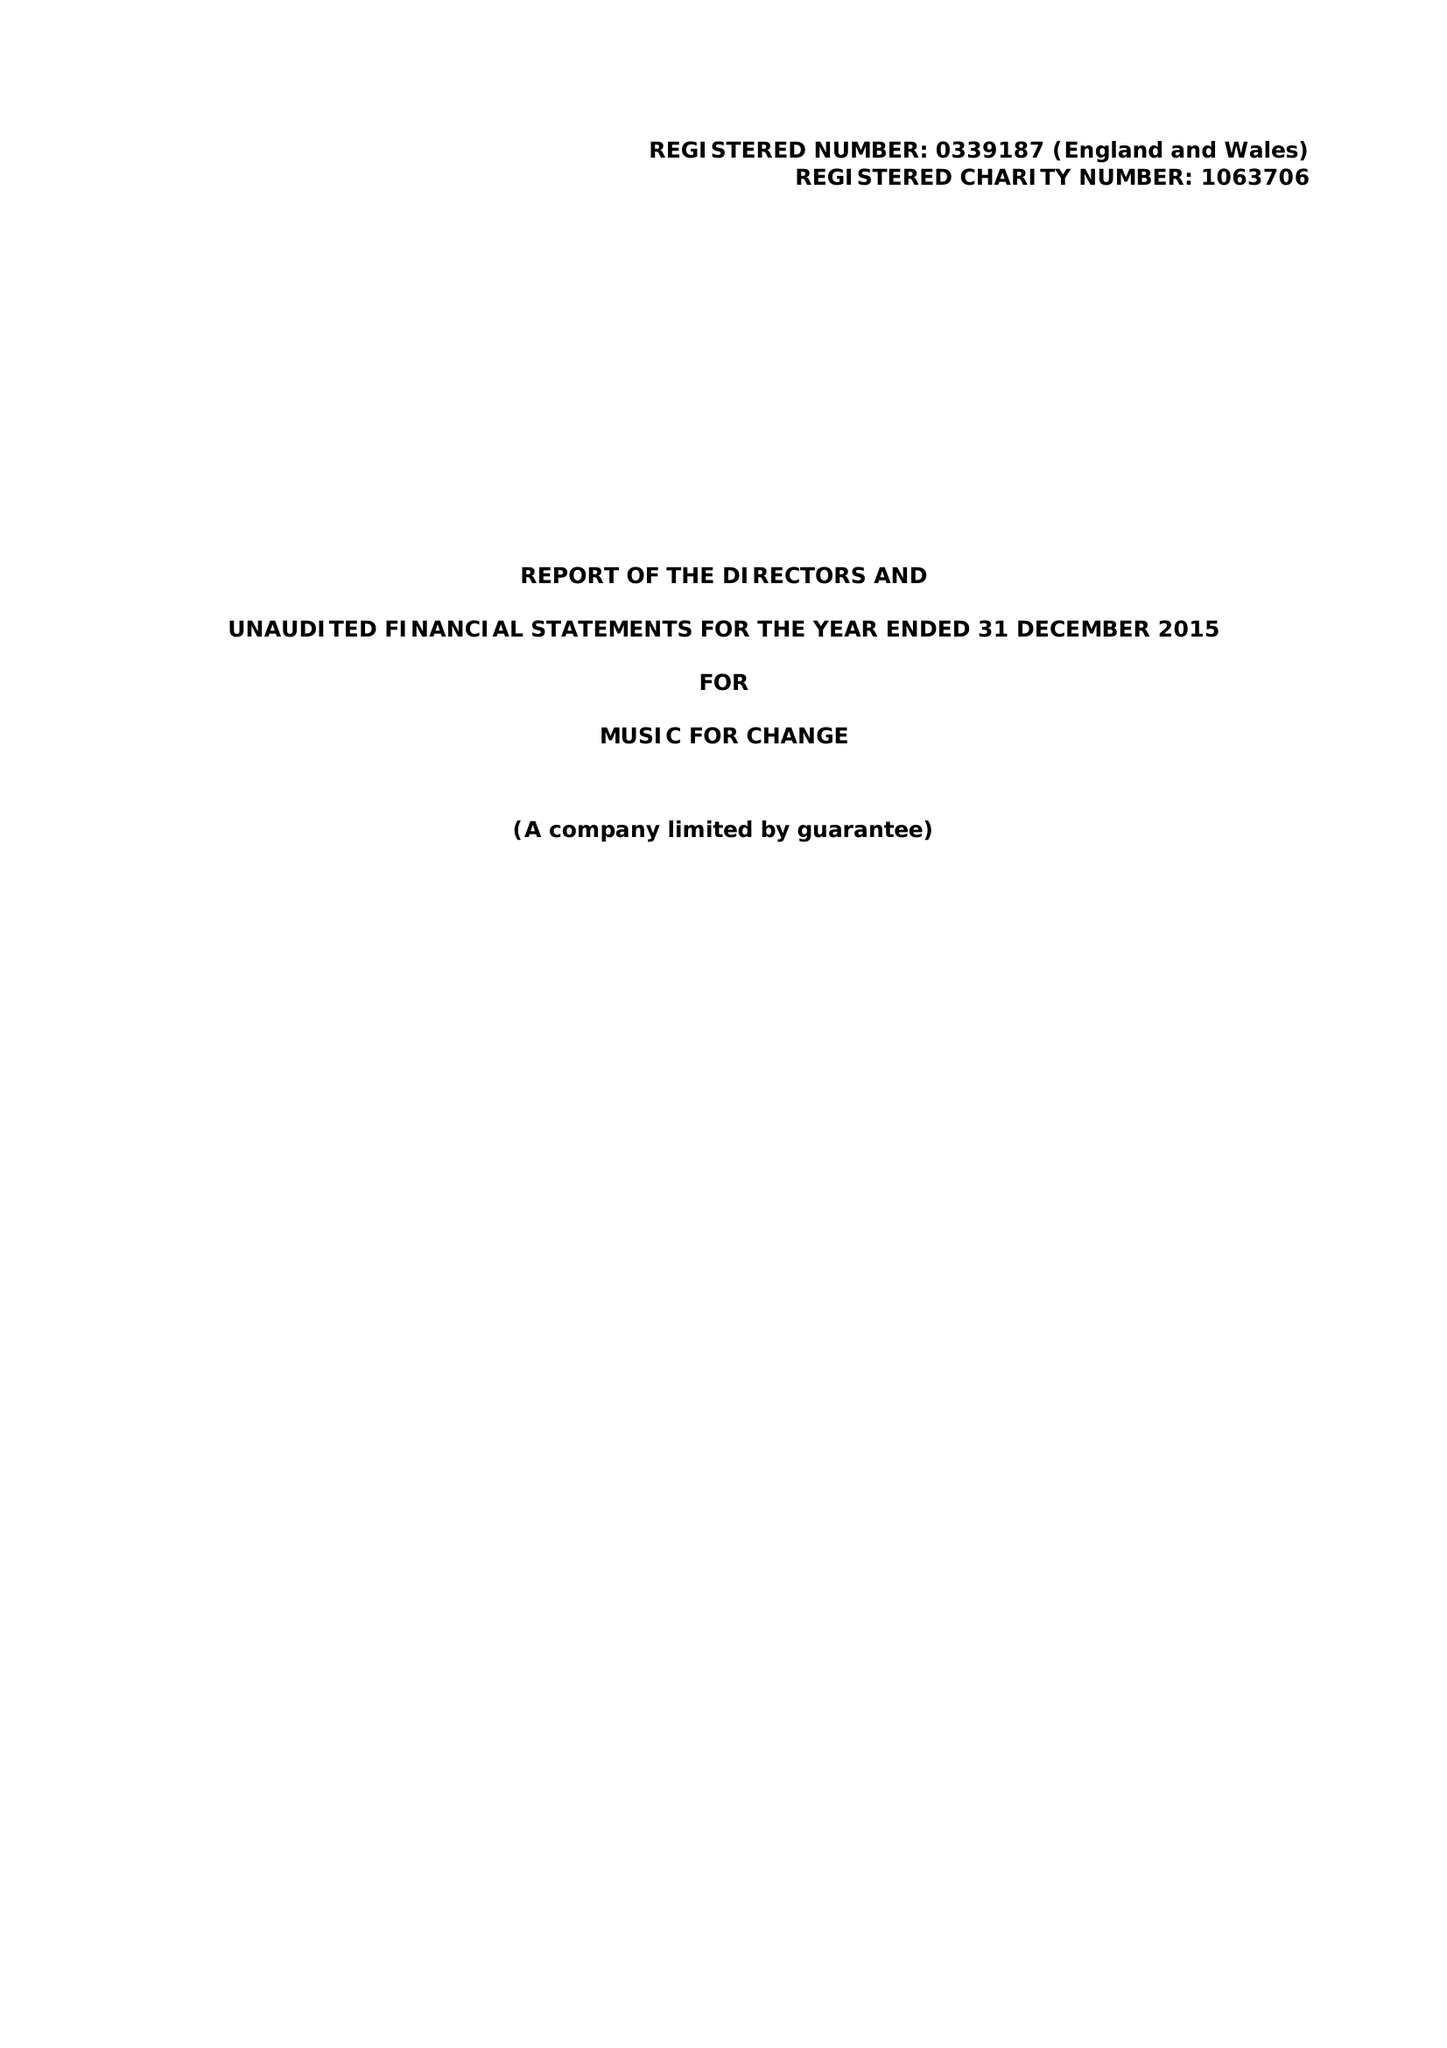What is the value for the address__street_line?
Answer the question using a single word or phrase. 77 STOUR STREET 